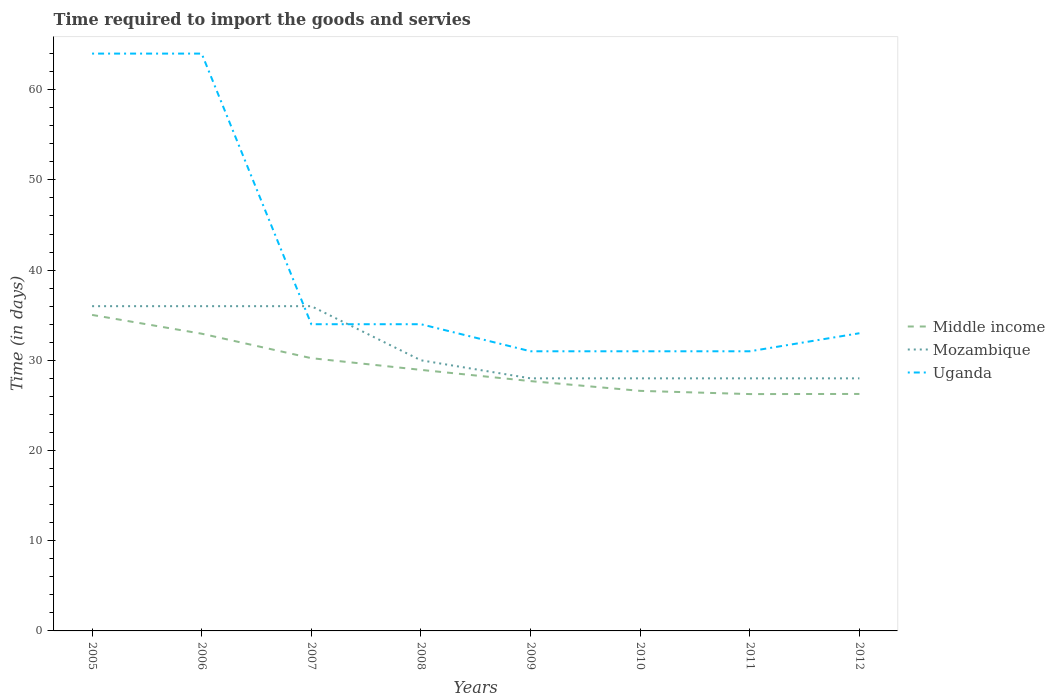How many different coloured lines are there?
Ensure brevity in your answer.  3. Is the number of lines equal to the number of legend labels?
Offer a terse response. Yes. Across all years, what is the maximum number of days required to import the goods and services in Mozambique?
Your answer should be very brief. 28. What is the total number of days required to import the goods and services in Mozambique in the graph?
Offer a terse response. 0. What is the difference between the highest and the second highest number of days required to import the goods and services in Uganda?
Offer a very short reply. 33. What is the difference between the highest and the lowest number of days required to import the goods and services in Mozambique?
Your answer should be very brief. 3. Is the number of days required to import the goods and services in Middle income strictly greater than the number of days required to import the goods and services in Mozambique over the years?
Keep it short and to the point. Yes. How many lines are there?
Give a very brief answer. 3. What is the difference between two consecutive major ticks on the Y-axis?
Make the answer very short. 10. Are the values on the major ticks of Y-axis written in scientific E-notation?
Your answer should be compact. No. How many legend labels are there?
Keep it short and to the point. 3. How are the legend labels stacked?
Your answer should be compact. Vertical. What is the title of the graph?
Ensure brevity in your answer.  Time required to import the goods and servies. Does "Peru" appear as one of the legend labels in the graph?
Give a very brief answer. No. What is the label or title of the X-axis?
Your answer should be compact. Years. What is the label or title of the Y-axis?
Make the answer very short. Time (in days). What is the Time (in days) of Middle income in 2005?
Provide a short and direct response. 35.03. What is the Time (in days) of Uganda in 2005?
Offer a terse response. 64. What is the Time (in days) of Middle income in 2006?
Offer a very short reply. 32.95. What is the Time (in days) of Middle income in 2007?
Provide a succinct answer. 30.24. What is the Time (in days) in Uganda in 2007?
Keep it short and to the point. 34. What is the Time (in days) of Middle income in 2008?
Ensure brevity in your answer.  28.94. What is the Time (in days) of Uganda in 2008?
Provide a short and direct response. 34. What is the Time (in days) in Middle income in 2009?
Give a very brief answer. 27.69. What is the Time (in days) of Uganda in 2009?
Offer a terse response. 31. What is the Time (in days) in Middle income in 2010?
Provide a short and direct response. 26.61. What is the Time (in days) of Mozambique in 2010?
Ensure brevity in your answer.  28. What is the Time (in days) of Middle income in 2011?
Your response must be concise. 26.26. What is the Time (in days) in Middle income in 2012?
Make the answer very short. 26.27. What is the Time (in days) in Mozambique in 2012?
Offer a very short reply. 28. What is the Time (in days) in Uganda in 2012?
Make the answer very short. 33. Across all years, what is the maximum Time (in days) in Middle income?
Give a very brief answer. 35.03. Across all years, what is the minimum Time (in days) in Middle income?
Offer a terse response. 26.26. Across all years, what is the minimum Time (in days) of Uganda?
Your answer should be very brief. 31. What is the total Time (in days) in Middle income in the graph?
Offer a very short reply. 233.99. What is the total Time (in days) of Mozambique in the graph?
Make the answer very short. 250. What is the total Time (in days) in Uganda in the graph?
Make the answer very short. 322. What is the difference between the Time (in days) in Middle income in 2005 and that in 2006?
Offer a terse response. 2.08. What is the difference between the Time (in days) in Mozambique in 2005 and that in 2006?
Ensure brevity in your answer.  0. What is the difference between the Time (in days) in Middle income in 2005 and that in 2007?
Your answer should be very brief. 4.79. What is the difference between the Time (in days) of Uganda in 2005 and that in 2007?
Offer a very short reply. 30. What is the difference between the Time (in days) in Middle income in 2005 and that in 2008?
Your answer should be compact. 6.09. What is the difference between the Time (in days) in Mozambique in 2005 and that in 2008?
Provide a succinct answer. 6. What is the difference between the Time (in days) of Middle income in 2005 and that in 2009?
Give a very brief answer. 7.34. What is the difference between the Time (in days) of Mozambique in 2005 and that in 2009?
Provide a succinct answer. 8. What is the difference between the Time (in days) in Middle income in 2005 and that in 2010?
Provide a succinct answer. 8.42. What is the difference between the Time (in days) of Uganda in 2005 and that in 2010?
Give a very brief answer. 33. What is the difference between the Time (in days) in Middle income in 2005 and that in 2011?
Make the answer very short. 8.78. What is the difference between the Time (in days) in Uganda in 2005 and that in 2011?
Provide a short and direct response. 33. What is the difference between the Time (in days) of Middle income in 2005 and that in 2012?
Your response must be concise. 8.76. What is the difference between the Time (in days) of Mozambique in 2005 and that in 2012?
Your answer should be very brief. 8. What is the difference between the Time (in days) of Uganda in 2005 and that in 2012?
Your response must be concise. 31. What is the difference between the Time (in days) in Middle income in 2006 and that in 2007?
Offer a very short reply. 2.71. What is the difference between the Time (in days) of Middle income in 2006 and that in 2008?
Offer a terse response. 4.01. What is the difference between the Time (in days) of Mozambique in 2006 and that in 2008?
Offer a terse response. 6. What is the difference between the Time (in days) in Uganda in 2006 and that in 2008?
Your response must be concise. 30. What is the difference between the Time (in days) of Middle income in 2006 and that in 2009?
Your answer should be very brief. 5.25. What is the difference between the Time (in days) of Mozambique in 2006 and that in 2009?
Provide a succinct answer. 8. What is the difference between the Time (in days) of Middle income in 2006 and that in 2010?
Ensure brevity in your answer.  6.34. What is the difference between the Time (in days) of Uganda in 2006 and that in 2010?
Give a very brief answer. 33. What is the difference between the Time (in days) of Middle income in 2006 and that in 2011?
Your response must be concise. 6.69. What is the difference between the Time (in days) of Middle income in 2006 and that in 2012?
Keep it short and to the point. 6.68. What is the difference between the Time (in days) in Middle income in 2007 and that in 2008?
Your response must be concise. 1.3. What is the difference between the Time (in days) of Mozambique in 2007 and that in 2008?
Your response must be concise. 6. What is the difference between the Time (in days) of Uganda in 2007 and that in 2008?
Provide a succinct answer. 0. What is the difference between the Time (in days) of Middle income in 2007 and that in 2009?
Your answer should be very brief. 2.54. What is the difference between the Time (in days) in Uganda in 2007 and that in 2009?
Your answer should be compact. 3. What is the difference between the Time (in days) in Middle income in 2007 and that in 2010?
Provide a succinct answer. 3.62. What is the difference between the Time (in days) in Mozambique in 2007 and that in 2010?
Ensure brevity in your answer.  8. What is the difference between the Time (in days) in Uganda in 2007 and that in 2010?
Offer a terse response. 3. What is the difference between the Time (in days) of Middle income in 2007 and that in 2011?
Your answer should be compact. 3.98. What is the difference between the Time (in days) in Uganda in 2007 and that in 2011?
Provide a succinct answer. 3. What is the difference between the Time (in days) of Middle income in 2007 and that in 2012?
Provide a short and direct response. 3.97. What is the difference between the Time (in days) in Mozambique in 2007 and that in 2012?
Provide a short and direct response. 8. What is the difference between the Time (in days) of Uganda in 2007 and that in 2012?
Offer a terse response. 1. What is the difference between the Time (in days) in Middle income in 2008 and that in 2009?
Your answer should be very brief. 1.24. What is the difference between the Time (in days) of Mozambique in 2008 and that in 2009?
Provide a succinct answer. 2. What is the difference between the Time (in days) of Uganda in 2008 and that in 2009?
Your answer should be compact. 3. What is the difference between the Time (in days) in Middle income in 2008 and that in 2010?
Offer a terse response. 2.33. What is the difference between the Time (in days) of Middle income in 2008 and that in 2011?
Offer a terse response. 2.68. What is the difference between the Time (in days) in Mozambique in 2008 and that in 2011?
Offer a very short reply. 2. What is the difference between the Time (in days) of Uganda in 2008 and that in 2011?
Keep it short and to the point. 3. What is the difference between the Time (in days) in Middle income in 2008 and that in 2012?
Give a very brief answer. 2.67. What is the difference between the Time (in days) in Middle income in 2009 and that in 2010?
Keep it short and to the point. 1.08. What is the difference between the Time (in days) of Mozambique in 2009 and that in 2010?
Ensure brevity in your answer.  0. What is the difference between the Time (in days) in Uganda in 2009 and that in 2010?
Your answer should be compact. 0. What is the difference between the Time (in days) of Middle income in 2009 and that in 2011?
Keep it short and to the point. 1.44. What is the difference between the Time (in days) of Middle income in 2009 and that in 2012?
Make the answer very short. 1.42. What is the difference between the Time (in days) of Mozambique in 2009 and that in 2012?
Offer a terse response. 0. What is the difference between the Time (in days) in Uganda in 2009 and that in 2012?
Provide a short and direct response. -2. What is the difference between the Time (in days) in Middle income in 2010 and that in 2011?
Keep it short and to the point. 0.36. What is the difference between the Time (in days) of Uganda in 2010 and that in 2011?
Ensure brevity in your answer.  0. What is the difference between the Time (in days) in Middle income in 2010 and that in 2012?
Your answer should be compact. 0.34. What is the difference between the Time (in days) in Mozambique in 2010 and that in 2012?
Keep it short and to the point. 0. What is the difference between the Time (in days) of Uganda in 2010 and that in 2012?
Offer a terse response. -2. What is the difference between the Time (in days) in Middle income in 2011 and that in 2012?
Give a very brief answer. -0.01. What is the difference between the Time (in days) in Uganda in 2011 and that in 2012?
Offer a very short reply. -2. What is the difference between the Time (in days) of Middle income in 2005 and the Time (in days) of Mozambique in 2006?
Provide a succinct answer. -0.97. What is the difference between the Time (in days) in Middle income in 2005 and the Time (in days) in Uganda in 2006?
Provide a short and direct response. -28.97. What is the difference between the Time (in days) of Mozambique in 2005 and the Time (in days) of Uganda in 2006?
Provide a succinct answer. -28. What is the difference between the Time (in days) of Middle income in 2005 and the Time (in days) of Mozambique in 2007?
Your response must be concise. -0.97. What is the difference between the Time (in days) in Middle income in 2005 and the Time (in days) in Uganda in 2007?
Keep it short and to the point. 1.03. What is the difference between the Time (in days) in Mozambique in 2005 and the Time (in days) in Uganda in 2007?
Your answer should be compact. 2. What is the difference between the Time (in days) in Middle income in 2005 and the Time (in days) in Mozambique in 2008?
Give a very brief answer. 5.03. What is the difference between the Time (in days) of Middle income in 2005 and the Time (in days) of Uganda in 2008?
Your answer should be very brief. 1.03. What is the difference between the Time (in days) in Middle income in 2005 and the Time (in days) in Mozambique in 2009?
Provide a short and direct response. 7.03. What is the difference between the Time (in days) of Middle income in 2005 and the Time (in days) of Uganda in 2009?
Your answer should be very brief. 4.03. What is the difference between the Time (in days) of Mozambique in 2005 and the Time (in days) of Uganda in 2009?
Offer a very short reply. 5. What is the difference between the Time (in days) of Middle income in 2005 and the Time (in days) of Mozambique in 2010?
Make the answer very short. 7.03. What is the difference between the Time (in days) of Middle income in 2005 and the Time (in days) of Uganda in 2010?
Ensure brevity in your answer.  4.03. What is the difference between the Time (in days) of Mozambique in 2005 and the Time (in days) of Uganda in 2010?
Provide a short and direct response. 5. What is the difference between the Time (in days) of Middle income in 2005 and the Time (in days) of Mozambique in 2011?
Give a very brief answer. 7.03. What is the difference between the Time (in days) in Middle income in 2005 and the Time (in days) in Uganda in 2011?
Offer a terse response. 4.03. What is the difference between the Time (in days) in Mozambique in 2005 and the Time (in days) in Uganda in 2011?
Your response must be concise. 5. What is the difference between the Time (in days) of Middle income in 2005 and the Time (in days) of Mozambique in 2012?
Provide a succinct answer. 7.03. What is the difference between the Time (in days) of Middle income in 2005 and the Time (in days) of Uganda in 2012?
Provide a short and direct response. 2.03. What is the difference between the Time (in days) of Middle income in 2006 and the Time (in days) of Mozambique in 2007?
Offer a terse response. -3.05. What is the difference between the Time (in days) in Middle income in 2006 and the Time (in days) in Uganda in 2007?
Provide a succinct answer. -1.05. What is the difference between the Time (in days) in Mozambique in 2006 and the Time (in days) in Uganda in 2007?
Offer a terse response. 2. What is the difference between the Time (in days) in Middle income in 2006 and the Time (in days) in Mozambique in 2008?
Offer a terse response. 2.95. What is the difference between the Time (in days) of Middle income in 2006 and the Time (in days) of Uganda in 2008?
Make the answer very short. -1.05. What is the difference between the Time (in days) of Middle income in 2006 and the Time (in days) of Mozambique in 2009?
Provide a short and direct response. 4.95. What is the difference between the Time (in days) of Middle income in 2006 and the Time (in days) of Uganda in 2009?
Your answer should be very brief. 1.95. What is the difference between the Time (in days) of Mozambique in 2006 and the Time (in days) of Uganda in 2009?
Your answer should be compact. 5. What is the difference between the Time (in days) in Middle income in 2006 and the Time (in days) in Mozambique in 2010?
Offer a very short reply. 4.95. What is the difference between the Time (in days) of Middle income in 2006 and the Time (in days) of Uganda in 2010?
Provide a short and direct response. 1.95. What is the difference between the Time (in days) of Mozambique in 2006 and the Time (in days) of Uganda in 2010?
Your answer should be very brief. 5. What is the difference between the Time (in days) of Middle income in 2006 and the Time (in days) of Mozambique in 2011?
Offer a very short reply. 4.95. What is the difference between the Time (in days) of Middle income in 2006 and the Time (in days) of Uganda in 2011?
Your answer should be compact. 1.95. What is the difference between the Time (in days) of Mozambique in 2006 and the Time (in days) of Uganda in 2011?
Give a very brief answer. 5. What is the difference between the Time (in days) in Middle income in 2006 and the Time (in days) in Mozambique in 2012?
Provide a succinct answer. 4.95. What is the difference between the Time (in days) in Middle income in 2006 and the Time (in days) in Uganda in 2012?
Give a very brief answer. -0.05. What is the difference between the Time (in days) in Middle income in 2007 and the Time (in days) in Mozambique in 2008?
Your answer should be very brief. 0.24. What is the difference between the Time (in days) of Middle income in 2007 and the Time (in days) of Uganda in 2008?
Your answer should be compact. -3.76. What is the difference between the Time (in days) in Mozambique in 2007 and the Time (in days) in Uganda in 2008?
Ensure brevity in your answer.  2. What is the difference between the Time (in days) of Middle income in 2007 and the Time (in days) of Mozambique in 2009?
Your response must be concise. 2.24. What is the difference between the Time (in days) of Middle income in 2007 and the Time (in days) of Uganda in 2009?
Your answer should be compact. -0.76. What is the difference between the Time (in days) of Middle income in 2007 and the Time (in days) of Mozambique in 2010?
Your response must be concise. 2.24. What is the difference between the Time (in days) in Middle income in 2007 and the Time (in days) in Uganda in 2010?
Offer a very short reply. -0.76. What is the difference between the Time (in days) in Middle income in 2007 and the Time (in days) in Mozambique in 2011?
Your response must be concise. 2.24. What is the difference between the Time (in days) of Middle income in 2007 and the Time (in days) of Uganda in 2011?
Make the answer very short. -0.76. What is the difference between the Time (in days) of Mozambique in 2007 and the Time (in days) of Uganda in 2011?
Offer a terse response. 5. What is the difference between the Time (in days) of Middle income in 2007 and the Time (in days) of Mozambique in 2012?
Offer a very short reply. 2.24. What is the difference between the Time (in days) of Middle income in 2007 and the Time (in days) of Uganda in 2012?
Your answer should be compact. -2.76. What is the difference between the Time (in days) of Mozambique in 2007 and the Time (in days) of Uganda in 2012?
Your response must be concise. 3. What is the difference between the Time (in days) of Middle income in 2008 and the Time (in days) of Mozambique in 2009?
Provide a short and direct response. 0.94. What is the difference between the Time (in days) of Middle income in 2008 and the Time (in days) of Uganda in 2009?
Ensure brevity in your answer.  -2.06. What is the difference between the Time (in days) of Middle income in 2008 and the Time (in days) of Mozambique in 2010?
Offer a very short reply. 0.94. What is the difference between the Time (in days) in Middle income in 2008 and the Time (in days) in Uganda in 2010?
Make the answer very short. -2.06. What is the difference between the Time (in days) in Mozambique in 2008 and the Time (in days) in Uganda in 2010?
Your response must be concise. -1. What is the difference between the Time (in days) of Middle income in 2008 and the Time (in days) of Mozambique in 2011?
Make the answer very short. 0.94. What is the difference between the Time (in days) of Middle income in 2008 and the Time (in days) of Uganda in 2011?
Your response must be concise. -2.06. What is the difference between the Time (in days) in Middle income in 2008 and the Time (in days) in Mozambique in 2012?
Offer a very short reply. 0.94. What is the difference between the Time (in days) in Middle income in 2008 and the Time (in days) in Uganda in 2012?
Keep it short and to the point. -4.06. What is the difference between the Time (in days) in Mozambique in 2008 and the Time (in days) in Uganda in 2012?
Keep it short and to the point. -3. What is the difference between the Time (in days) in Middle income in 2009 and the Time (in days) in Mozambique in 2010?
Offer a very short reply. -0.31. What is the difference between the Time (in days) in Middle income in 2009 and the Time (in days) in Uganda in 2010?
Offer a terse response. -3.31. What is the difference between the Time (in days) of Middle income in 2009 and the Time (in days) of Mozambique in 2011?
Offer a very short reply. -0.31. What is the difference between the Time (in days) of Middle income in 2009 and the Time (in days) of Uganda in 2011?
Offer a very short reply. -3.31. What is the difference between the Time (in days) in Mozambique in 2009 and the Time (in days) in Uganda in 2011?
Offer a very short reply. -3. What is the difference between the Time (in days) in Middle income in 2009 and the Time (in days) in Mozambique in 2012?
Provide a succinct answer. -0.31. What is the difference between the Time (in days) in Middle income in 2009 and the Time (in days) in Uganda in 2012?
Offer a very short reply. -5.31. What is the difference between the Time (in days) of Mozambique in 2009 and the Time (in days) of Uganda in 2012?
Provide a succinct answer. -5. What is the difference between the Time (in days) of Middle income in 2010 and the Time (in days) of Mozambique in 2011?
Offer a very short reply. -1.39. What is the difference between the Time (in days) in Middle income in 2010 and the Time (in days) in Uganda in 2011?
Your answer should be compact. -4.39. What is the difference between the Time (in days) in Middle income in 2010 and the Time (in days) in Mozambique in 2012?
Your answer should be compact. -1.39. What is the difference between the Time (in days) in Middle income in 2010 and the Time (in days) in Uganda in 2012?
Your answer should be very brief. -6.39. What is the difference between the Time (in days) in Middle income in 2011 and the Time (in days) in Mozambique in 2012?
Give a very brief answer. -1.74. What is the difference between the Time (in days) of Middle income in 2011 and the Time (in days) of Uganda in 2012?
Provide a short and direct response. -6.74. What is the average Time (in days) of Middle income per year?
Provide a short and direct response. 29.25. What is the average Time (in days) in Mozambique per year?
Offer a terse response. 31.25. What is the average Time (in days) in Uganda per year?
Your answer should be compact. 40.25. In the year 2005, what is the difference between the Time (in days) in Middle income and Time (in days) in Mozambique?
Provide a short and direct response. -0.97. In the year 2005, what is the difference between the Time (in days) in Middle income and Time (in days) in Uganda?
Ensure brevity in your answer.  -28.97. In the year 2005, what is the difference between the Time (in days) of Mozambique and Time (in days) of Uganda?
Your answer should be compact. -28. In the year 2006, what is the difference between the Time (in days) in Middle income and Time (in days) in Mozambique?
Your response must be concise. -3.05. In the year 2006, what is the difference between the Time (in days) in Middle income and Time (in days) in Uganda?
Keep it short and to the point. -31.05. In the year 2006, what is the difference between the Time (in days) in Mozambique and Time (in days) in Uganda?
Make the answer very short. -28. In the year 2007, what is the difference between the Time (in days) in Middle income and Time (in days) in Mozambique?
Your answer should be compact. -5.76. In the year 2007, what is the difference between the Time (in days) of Middle income and Time (in days) of Uganda?
Your answer should be compact. -3.76. In the year 2007, what is the difference between the Time (in days) of Mozambique and Time (in days) of Uganda?
Ensure brevity in your answer.  2. In the year 2008, what is the difference between the Time (in days) in Middle income and Time (in days) in Mozambique?
Offer a terse response. -1.06. In the year 2008, what is the difference between the Time (in days) of Middle income and Time (in days) of Uganda?
Your answer should be compact. -5.06. In the year 2009, what is the difference between the Time (in days) in Middle income and Time (in days) in Mozambique?
Your answer should be compact. -0.31. In the year 2009, what is the difference between the Time (in days) in Middle income and Time (in days) in Uganda?
Make the answer very short. -3.31. In the year 2009, what is the difference between the Time (in days) in Mozambique and Time (in days) in Uganda?
Offer a terse response. -3. In the year 2010, what is the difference between the Time (in days) in Middle income and Time (in days) in Mozambique?
Your answer should be very brief. -1.39. In the year 2010, what is the difference between the Time (in days) of Middle income and Time (in days) of Uganda?
Your answer should be very brief. -4.39. In the year 2010, what is the difference between the Time (in days) of Mozambique and Time (in days) of Uganda?
Provide a succinct answer. -3. In the year 2011, what is the difference between the Time (in days) of Middle income and Time (in days) of Mozambique?
Your response must be concise. -1.74. In the year 2011, what is the difference between the Time (in days) of Middle income and Time (in days) of Uganda?
Keep it short and to the point. -4.74. In the year 2012, what is the difference between the Time (in days) of Middle income and Time (in days) of Mozambique?
Your answer should be very brief. -1.73. In the year 2012, what is the difference between the Time (in days) in Middle income and Time (in days) in Uganda?
Provide a succinct answer. -6.73. What is the ratio of the Time (in days) in Middle income in 2005 to that in 2006?
Keep it short and to the point. 1.06. What is the ratio of the Time (in days) in Mozambique in 2005 to that in 2006?
Give a very brief answer. 1. What is the ratio of the Time (in days) in Middle income in 2005 to that in 2007?
Your response must be concise. 1.16. What is the ratio of the Time (in days) in Mozambique in 2005 to that in 2007?
Provide a succinct answer. 1. What is the ratio of the Time (in days) of Uganda in 2005 to that in 2007?
Offer a terse response. 1.88. What is the ratio of the Time (in days) of Middle income in 2005 to that in 2008?
Provide a succinct answer. 1.21. What is the ratio of the Time (in days) in Mozambique in 2005 to that in 2008?
Your answer should be very brief. 1.2. What is the ratio of the Time (in days) of Uganda in 2005 to that in 2008?
Your answer should be very brief. 1.88. What is the ratio of the Time (in days) of Middle income in 2005 to that in 2009?
Offer a very short reply. 1.26. What is the ratio of the Time (in days) of Uganda in 2005 to that in 2009?
Provide a short and direct response. 2.06. What is the ratio of the Time (in days) of Middle income in 2005 to that in 2010?
Give a very brief answer. 1.32. What is the ratio of the Time (in days) in Mozambique in 2005 to that in 2010?
Offer a terse response. 1.29. What is the ratio of the Time (in days) in Uganda in 2005 to that in 2010?
Offer a terse response. 2.06. What is the ratio of the Time (in days) in Middle income in 2005 to that in 2011?
Provide a succinct answer. 1.33. What is the ratio of the Time (in days) in Uganda in 2005 to that in 2011?
Your answer should be very brief. 2.06. What is the ratio of the Time (in days) in Middle income in 2005 to that in 2012?
Your response must be concise. 1.33. What is the ratio of the Time (in days) in Mozambique in 2005 to that in 2012?
Offer a very short reply. 1.29. What is the ratio of the Time (in days) in Uganda in 2005 to that in 2012?
Ensure brevity in your answer.  1.94. What is the ratio of the Time (in days) of Middle income in 2006 to that in 2007?
Provide a succinct answer. 1.09. What is the ratio of the Time (in days) in Mozambique in 2006 to that in 2007?
Your answer should be compact. 1. What is the ratio of the Time (in days) in Uganda in 2006 to that in 2007?
Your answer should be compact. 1.88. What is the ratio of the Time (in days) in Middle income in 2006 to that in 2008?
Keep it short and to the point. 1.14. What is the ratio of the Time (in days) of Uganda in 2006 to that in 2008?
Your response must be concise. 1.88. What is the ratio of the Time (in days) of Middle income in 2006 to that in 2009?
Your answer should be compact. 1.19. What is the ratio of the Time (in days) of Uganda in 2006 to that in 2009?
Provide a short and direct response. 2.06. What is the ratio of the Time (in days) of Middle income in 2006 to that in 2010?
Your response must be concise. 1.24. What is the ratio of the Time (in days) in Uganda in 2006 to that in 2010?
Your answer should be compact. 2.06. What is the ratio of the Time (in days) of Middle income in 2006 to that in 2011?
Your answer should be compact. 1.25. What is the ratio of the Time (in days) in Mozambique in 2006 to that in 2011?
Your response must be concise. 1.29. What is the ratio of the Time (in days) in Uganda in 2006 to that in 2011?
Offer a terse response. 2.06. What is the ratio of the Time (in days) of Middle income in 2006 to that in 2012?
Offer a terse response. 1.25. What is the ratio of the Time (in days) in Mozambique in 2006 to that in 2012?
Keep it short and to the point. 1.29. What is the ratio of the Time (in days) in Uganda in 2006 to that in 2012?
Ensure brevity in your answer.  1.94. What is the ratio of the Time (in days) in Middle income in 2007 to that in 2008?
Make the answer very short. 1.04. What is the ratio of the Time (in days) of Mozambique in 2007 to that in 2008?
Ensure brevity in your answer.  1.2. What is the ratio of the Time (in days) of Uganda in 2007 to that in 2008?
Make the answer very short. 1. What is the ratio of the Time (in days) of Middle income in 2007 to that in 2009?
Your answer should be very brief. 1.09. What is the ratio of the Time (in days) in Mozambique in 2007 to that in 2009?
Give a very brief answer. 1.29. What is the ratio of the Time (in days) in Uganda in 2007 to that in 2009?
Make the answer very short. 1.1. What is the ratio of the Time (in days) in Middle income in 2007 to that in 2010?
Your answer should be very brief. 1.14. What is the ratio of the Time (in days) of Uganda in 2007 to that in 2010?
Offer a terse response. 1.1. What is the ratio of the Time (in days) of Middle income in 2007 to that in 2011?
Your response must be concise. 1.15. What is the ratio of the Time (in days) of Uganda in 2007 to that in 2011?
Provide a succinct answer. 1.1. What is the ratio of the Time (in days) in Middle income in 2007 to that in 2012?
Provide a short and direct response. 1.15. What is the ratio of the Time (in days) in Uganda in 2007 to that in 2012?
Your answer should be very brief. 1.03. What is the ratio of the Time (in days) in Middle income in 2008 to that in 2009?
Make the answer very short. 1.04. What is the ratio of the Time (in days) in Mozambique in 2008 to that in 2009?
Keep it short and to the point. 1.07. What is the ratio of the Time (in days) of Uganda in 2008 to that in 2009?
Offer a very short reply. 1.1. What is the ratio of the Time (in days) in Middle income in 2008 to that in 2010?
Your answer should be very brief. 1.09. What is the ratio of the Time (in days) of Mozambique in 2008 to that in 2010?
Your answer should be compact. 1.07. What is the ratio of the Time (in days) of Uganda in 2008 to that in 2010?
Give a very brief answer. 1.1. What is the ratio of the Time (in days) of Middle income in 2008 to that in 2011?
Provide a succinct answer. 1.1. What is the ratio of the Time (in days) of Mozambique in 2008 to that in 2011?
Give a very brief answer. 1.07. What is the ratio of the Time (in days) of Uganda in 2008 to that in 2011?
Your answer should be compact. 1.1. What is the ratio of the Time (in days) of Middle income in 2008 to that in 2012?
Your answer should be compact. 1.1. What is the ratio of the Time (in days) in Mozambique in 2008 to that in 2012?
Provide a short and direct response. 1.07. What is the ratio of the Time (in days) of Uganda in 2008 to that in 2012?
Offer a very short reply. 1.03. What is the ratio of the Time (in days) of Middle income in 2009 to that in 2010?
Offer a very short reply. 1.04. What is the ratio of the Time (in days) of Uganda in 2009 to that in 2010?
Ensure brevity in your answer.  1. What is the ratio of the Time (in days) of Middle income in 2009 to that in 2011?
Your answer should be very brief. 1.05. What is the ratio of the Time (in days) in Mozambique in 2009 to that in 2011?
Keep it short and to the point. 1. What is the ratio of the Time (in days) in Middle income in 2009 to that in 2012?
Keep it short and to the point. 1.05. What is the ratio of the Time (in days) in Mozambique in 2009 to that in 2012?
Your response must be concise. 1. What is the ratio of the Time (in days) of Uganda in 2009 to that in 2012?
Keep it short and to the point. 0.94. What is the ratio of the Time (in days) in Middle income in 2010 to that in 2011?
Provide a short and direct response. 1.01. What is the ratio of the Time (in days) of Mozambique in 2010 to that in 2011?
Keep it short and to the point. 1. What is the ratio of the Time (in days) in Uganda in 2010 to that in 2011?
Keep it short and to the point. 1. What is the ratio of the Time (in days) of Uganda in 2010 to that in 2012?
Make the answer very short. 0.94. What is the ratio of the Time (in days) of Middle income in 2011 to that in 2012?
Your answer should be compact. 1. What is the ratio of the Time (in days) in Mozambique in 2011 to that in 2012?
Your answer should be compact. 1. What is the ratio of the Time (in days) in Uganda in 2011 to that in 2012?
Your answer should be compact. 0.94. What is the difference between the highest and the second highest Time (in days) in Middle income?
Make the answer very short. 2.08. What is the difference between the highest and the second highest Time (in days) of Uganda?
Offer a terse response. 0. What is the difference between the highest and the lowest Time (in days) in Middle income?
Offer a very short reply. 8.78. What is the difference between the highest and the lowest Time (in days) of Uganda?
Your answer should be very brief. 33. 